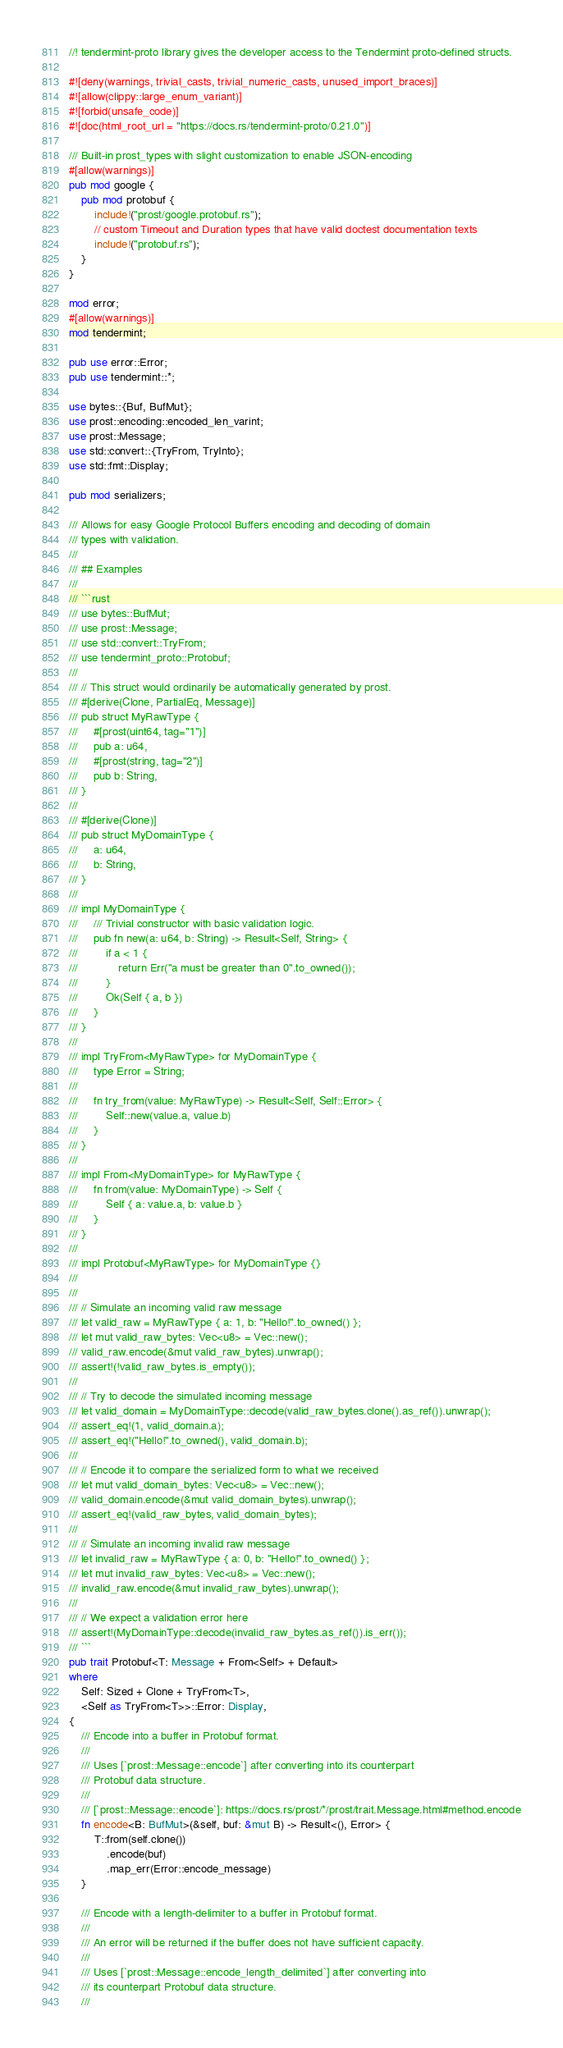Convert code to text. <code><loc_0><loc_0><loc_500><loc_500><_Rust_>//! tendermint-proto library gives the developer access to the Tendermint proto-defined structs.

#![deny(warnings, trivial_casts, trivial_numeric_casts, unused_import_braces)]
#![allow(clippy::large_enum_variant)]
#![forbid(unsafe_code)]
#![doc(html_root_url = "https://docs.rs/tendermint-proto/0.21.0")]

/// Built-in prost_types with slight customization to enable JSON-encoding
#[allow(warnings)]
pub mod google {
    pub mod protobuf {
        include!("prost/google.protobuf.rs");
        // custom Timeout and Duration types that have valid doctest documentation texts
        include!("protobuf.rs");
    }
}

mod error;
#[allow(warnings)]
mod tendermint;

pub use error::Error;
pub use tendermint::*;

use bytes::{Buf, BufMut};
use prost::encoding::encoded_len_varint;
use prost::Message;
use std::convert::{TryFrom, TryInto};
use std::fmt::Display;

pub mod serializers;

/// Allows for easy Google Protocol Buffers encoding and decoding of domain
/// types with validation.
///
/// ## Examples
///
/// ```rust
/// use bytes::BufMut;
/// use prost::Message;
/// use std::convert::TryFrom;
/// use tendermint_proto::Protobuf;
///
/// // This struct would ordinarily be automatically generated by prost.
/// #[derive(Clone, PartialEq, Message)]
/// pub struct MyRawType {
///     #[prost(uint64, tag="1")]
///     pub a: u64,
///     #[prost(string, tag="2")]
///     pub b: String,
/// }
///
/// #[derive(Clone)]
/// pub struct MyDomainType {
///     a: u64,
///     b: String,
/// }
///
/// impl MyDomainType {
///     /// Trivial constructor with basic validation logic.
///     pub fn new(a: u64, b: String) -> Result<Self, String> {
///         if a < 1 {
///             return Err("a must be greater than 0".to_owned());
///         }
///         Ok(Self { a, b })
///     }
/// }
///
/// impl TryFrom<MyRawType> for MyDomainType {
///     type Error = String;
///
///     fn try_from(value: MyRawType) -> Result<Self, Self::Error> {
///         Self::new(value.a, value.b)
///     }
/// }
///
/// impl From<MyDomainType> for MyRawType {
///     fn from(value: MyDomainType) -> Self {
///         Self { a: value.a, b: value.b }
///     }
/// }
///
/// impl Protobuf<MyRawType> for MyDomainType {}
///
///
/// // Simulate an incoming valid raw message
/// let valid_raw = MyRawType { a: 1, b: "Hello!".to_owned() };
/// let mut valid_raw_bytes: Vec<u8> = Vec::new();
/// valid_raw.encode(&mut valid_raw_bytes).unwrap();
/// assert!(!valid_raw_bytes.is_empty());
///
/// // Try to decode the simulated incoming message
/// let valid_domain = MyDomainType::decode(valid_raw_bytes.clone().as_ref()).unwrap();
/// assert_eq!(1, valid_domain.a);
/// assert_eq!("Hello!".to_owned(), valid_domain.b);
///
/// // Encode it to compare the serialized form to what we received
/// let mut valid_domain_bytes: Vec<u8> = Vec::new();
/// valid_domain.encode(&mut valid_domain_bytes).unwrap();
/// assert_eq!(valid_raw_bytes, valid_domain_bytes);
///
/// // Simulate an incoming invalid raw message
/// let invalid_raw = MyRawType { a: 0, b: "Hello!".to_owned() };
/// let mut invalid_raw_bytes: Vec<u8> = Vec::new();
/// invalid_raw.encode(&mut invalid_raw_bytes).unwrap();
///
/// // We expect a validation error here
/// assert!(MyDomainType::decode(invalid_raw_bytes.as_ref()).is_err());
/// ```
pub trait Protobuf<T: Message + From<Self> + Default>
where
    Self: Sized + Clone + TryFrom<T>,
    <Self as TryFrom<T>>::Error: Display,
{
    /// Encode into a buffer in Protobuf format.
    ///
    /// Uses [`prost::Message::encode`] after converting into its counterpart
    /// Protobuf data structure.
    ///
    /// [`prost::Message::encode`]: https://docs.rs/prost/*/prost/trait.Message.html#method.encode
    fn encode<B: BufMut>(&self, buf: &mut B) -> Result<(), Error> {
        T::from(self.clone())
            .encode(buf)
            .map_err(Error::encode_message)
    }

    /// Encode with a length-delimiter to a buffer in Protobuf format.
    ///
    /// An error will be returned if the buffer does not have sufficient capacity.
    ///
    /// Uses [`prost::Message::encode_length_delimited`] after converting into
    /// its counterpart Protobuf data structure.
    ///</code> 